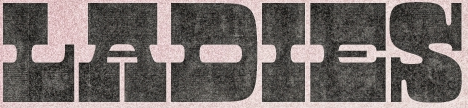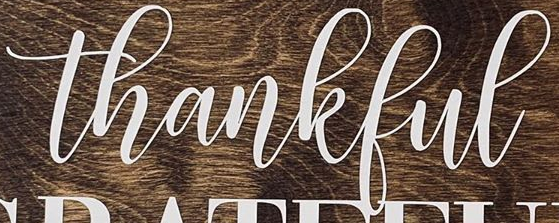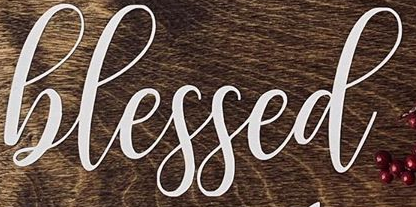What text appears in these images from left to right, separated by a semicolon? LADIES; thankful; hlessed 